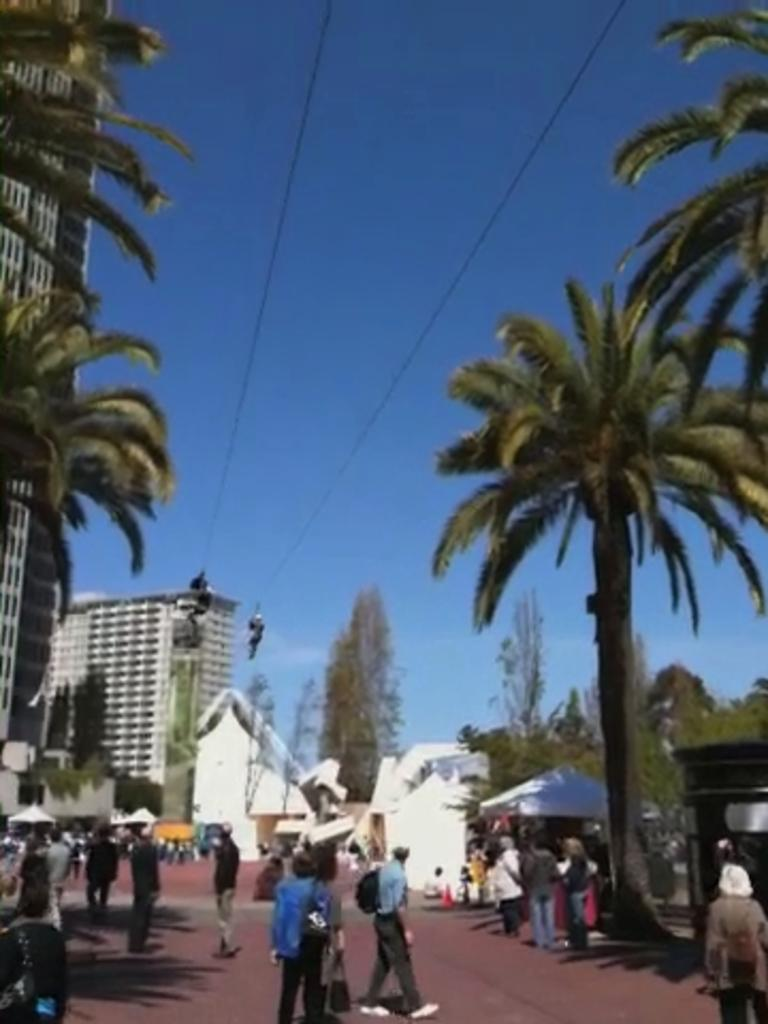What are the people in the image doing? There are many people walking on the road in the image. What can be seen on either side of the road? There are trees and buildings visible on either side of the road. What is visible above the road? The sky is visible above the road. Can you describe the ornament hanging from the tree on the left side of the road? There is no ornament hanging from the tree on the left side of the road in the image. Is there a beggar visible on the road in the image? There is no mention of a beggar in the provided facts, and therefore we cannot determine if one is present in the image. 